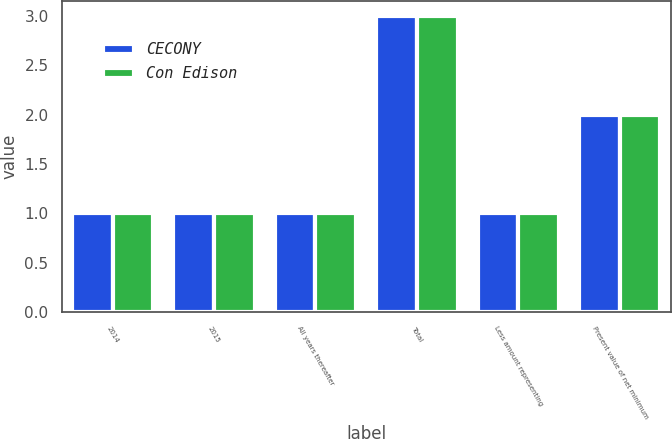Convert chart to OTSL. <chart><loc_0><loc_0><loc_500><loc_500><stacked_bar_chart><ecel><fcel>2014<fcel>2015<fcel>All years thereafter<fcel>Total<fcel>Less amount representing<fcel>Present value of net minimum<nl><fcel>CECONY<fcel>1<fcel>1<fcel>1<fcel>3<fcel>1<fcel>2<nl><fcel>Con Edison<fcel>1<fcel>1<fcel>1<fcel>3<fcel>1<fcel>2<nl></chart> 